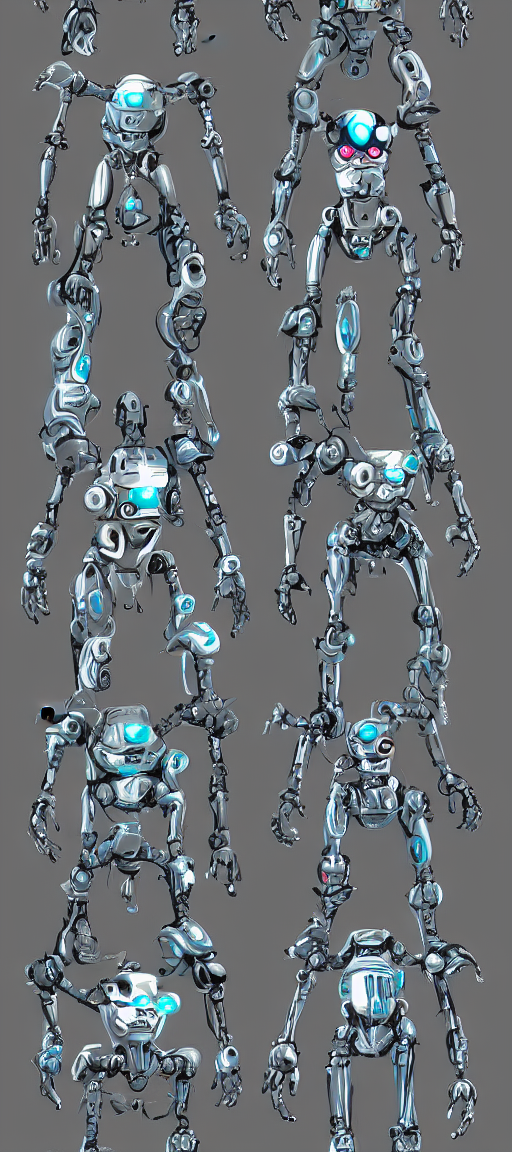What can be said about the colors in this image?
A. Mono-toned
B. Dull
C. Colorless
D. Rich The image features a range of metallic blues, grays, and subtle hints of other cool tones that blend harmoniously. This palette creates a visually rich and aesthetically pleasing effect, resonating with option D. The colors are not monotonous as they display variety, neither are they dull as the metallic sheen adds vibrancy, nor colorless, as blue is significantly present. 